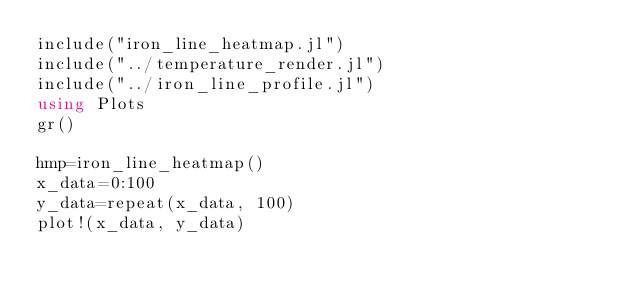Convert code to text. <code><loc_0><loc_0><loc_500><loc_500><_Julia_>include("iron_line_heatmap.jl")
include("../temperature_render.jl")
include("../iron_line_profile.jl")
using Plots
gr()

hmp=iron_line_heatmap()
x_data=0:100
y_data=repeat(x_data, 100)
plot!(x_data, y_data)</code> 